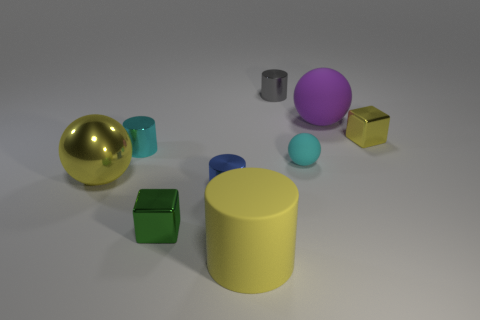Is the color of the rubber cylinder the same as the metallic ball?
Keep it short and to the point. Yes. The cylinder right of the big matte object in front of the large ball left of the small blue cylinder is what color?
Provide a succinct answer. Gray. Is there a small cyan thing that has the same shape as the large purple thing?
Provide a short and direct response. Yes. Is the number of blocks on the left side of the yellow cylinder greater than the number of large green cubes?
Offer a terse response. Yes. What number of rubber things are blue objects or tiny green cylinders?
Give a very brief answer. 0. What size is the yellow thing that is in front of the small matte thing and right of the small green shiny cube?
Offer a terse response. Large. Is there a gray shiny object on the right side of the cyan thing that is left of the blue metal object?
Give a very brief answer. Yes. How many cyan things are behind the large yellow shiny sphere?
Offer a terse response. 2. What is the color of the big matte thing that is the same shape as the tiny blue metal object?
Make the answer very short. Yellow. Are the large sphere that is behind the small ball and the tiny cylinder to the right of the yellow matte thing made of the same material?
Give a very brief answer. No. 